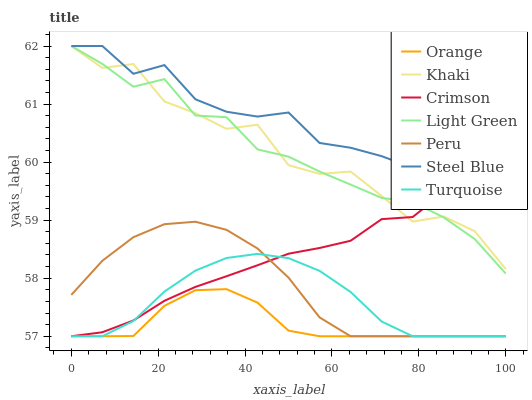Does Orange have the minimum area under the curve?
Answer yes or no. Yes. Does Steel Blue have the maximum area under the curve?
Answer yes or no. Yes. Does Khaki have the minimum area under the curve?
Answer yes or no. No. Does Khaki have the maximum area under the curve?
Answer yes or no. No. Is Peru the smoothest?
Answer yes or no. Yes. Is Khaki the roughest?
Answer yes or no. Yes. Is Light Green the smoothest?
Answer yes or no. No. Is Light Green the roughest?
Answer yes or no. No. Does Turquoise have the lowest value?
Answer yes or no. Yes. Does Khaki have the lowest value?
Answer yes or no. No. Does Steel Blue have the highest value?
Answer yes or no. Yes. Does Crimson have the highest value?
Answer yes or no. No. Is Turquoise less than Steel Blue?
Answer yes or no. Yes. Is Khaki greater than Peru?
Answer yes or no. Yes. Does Crimson intersect Turquoise?
Answer yes or no. Yes. Is Crimson less than Turquoise?
Answer yes or no. No. Is Crimson greater than Turquoise?
Answer yes or no. No. Does Turquoise intersect Steel Blue?
Answer yes or no. No. 